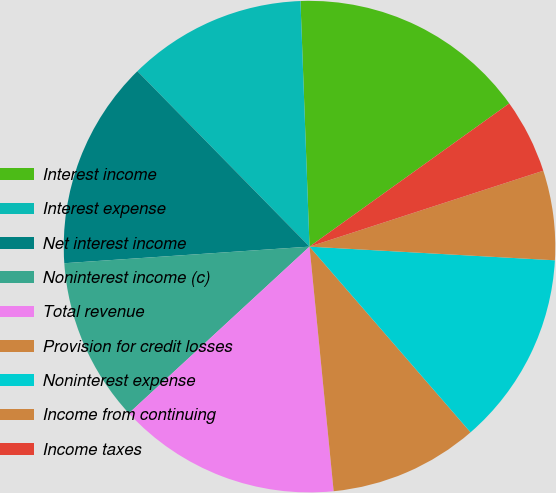Convert chart to OTSL. <chart><loc_0><loc_0><loc_500><loc_500><pie_chart><fcel>Interest income<fcel>Interest expense<fcel>Net interest income<fcel>Noninterest income (c)<fcel>Total revenue<fcel>Provision for credit losses<fcel>Noninterest expense<fcel>Income from continuing<fcel>Income taxes<nl><fcel>15.68%<fcel>11.76%<fcel>13.72%<fcel>10.78%<fcel>14.7%<fcel>9.8%<fcel>12.74%<fcel>5.88%<fcel>4.9%<nl></chart> 